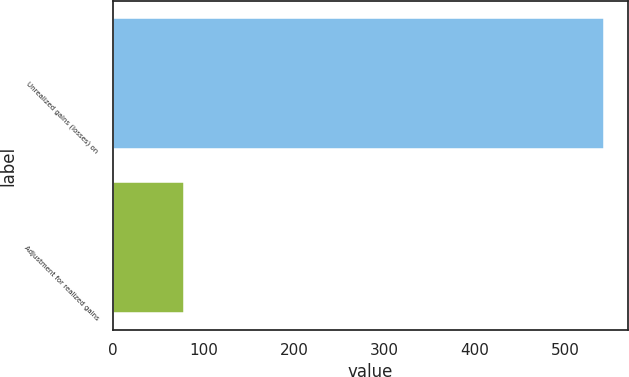Convert chart to OTSL. <chart><loc_0><loc_0><loc_500><loc_500><bar_chart><fcel>Unrealized gains (losses) on<fcel>Adjustment for realized gains<nl><fcel>541.9<fcel>78.7<nl></chart> 